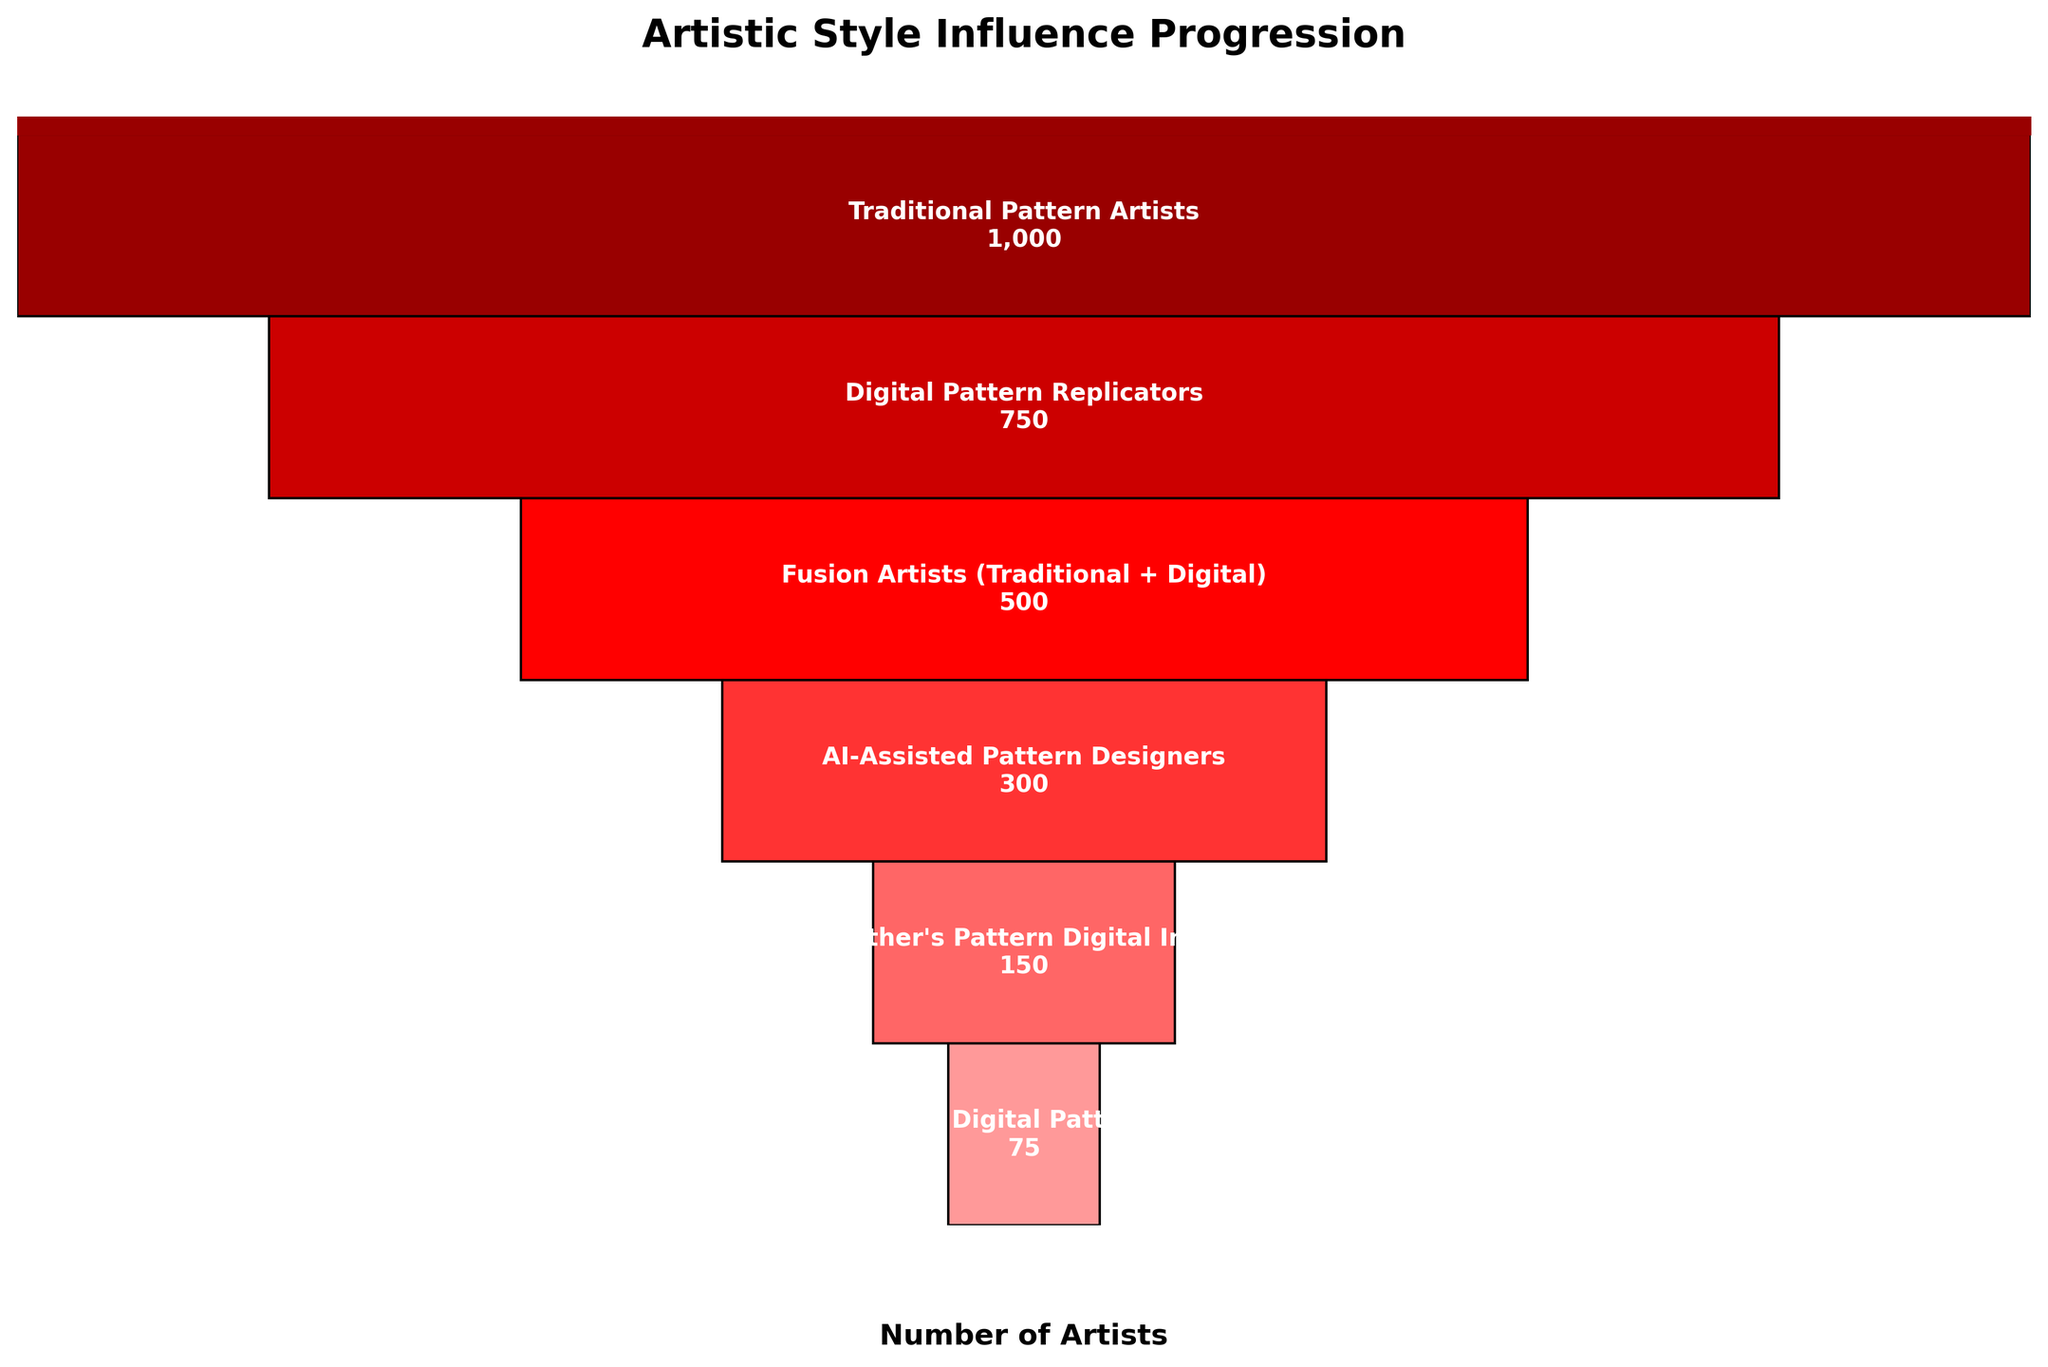What's the title of the figure? The title of the figure is written at the top of the chart. It states what the chart is about.
Answer: Artistic Style Influence Progression How many stages are represented in the funnel chart? The funnel chart shows different stages, each representing a group of artists. By counting the distinct stages listed from top to bottom, we get the total number.
Answer: 6 Which stage has the highest number of artists? By looking at the chart, the width of each stage represents the number of artists. The widest stage, therefore, has the highest number. The top stage is the widest.
Answer: Traditional Pattern Artists How many artists are in the AI-Assisted Pattern Designers stage? The chart lists the number of artists for each stage. By identifying the AI-Assisted Pattern Designers stage and checking its value, the number can be found.
Answer: 300 What is the difference in the number of artists between Fusion Artists and Digital Pattern Replicators? Fusion Artists have 500 artists and Digital Pattern Replicators have 750 artists. Subtract the smaller number from the larger one to get the difference. 750 - 500 = 250
Answer: 250 What's the total number of artists across all stages? To find the total, add up the number of artists from each stage: 1000 (Traditional) + 750 (Digital Replicators) + 500 (Fusion) + 300 (AI-Assisted) + 150 (Grandmother's Pattern) + 75 (Avant-Garde).
Answer: 2775 Which stage has the lowest number of artists? The narrowest and the bottom-most stage represents the smallest number of artists.
Answer: Avant-Garde Digital Pattern Creators How many more artists are Traditional Pattern Artists compared to Grandmother's Pattern Digital Innovators? Traditional Pattern Artists have 1000 artists, and Grandmother's Pattern Digital Innovators have 150 artists. Subtract the smaller number from the larger one: 1000 - 150 = 850
Answer: 850 How do the number of Fusion Artists compare with Avant-Garde Digital Pattern Creators? Fusion Artists have 500 artists and Avant-Garde Digital Pattern Creators have 75 artists. Comparing the two, Fusion Artists have more.
Answer: More What is the average number of artists across all stages? To find the average, divide the total number of artists by the number of stages. The total is 2775, and there are 6 stages. 2775 / 6 = 462.5
Answer: 462.5 